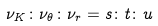Convert formula to latex. <formula><loc_0><loc_0><loc_500><loc_500>\nu _ { K } \colon \nu _ { \theta } \colon \nu _ { r } = s \colon t \colon u</formula> 